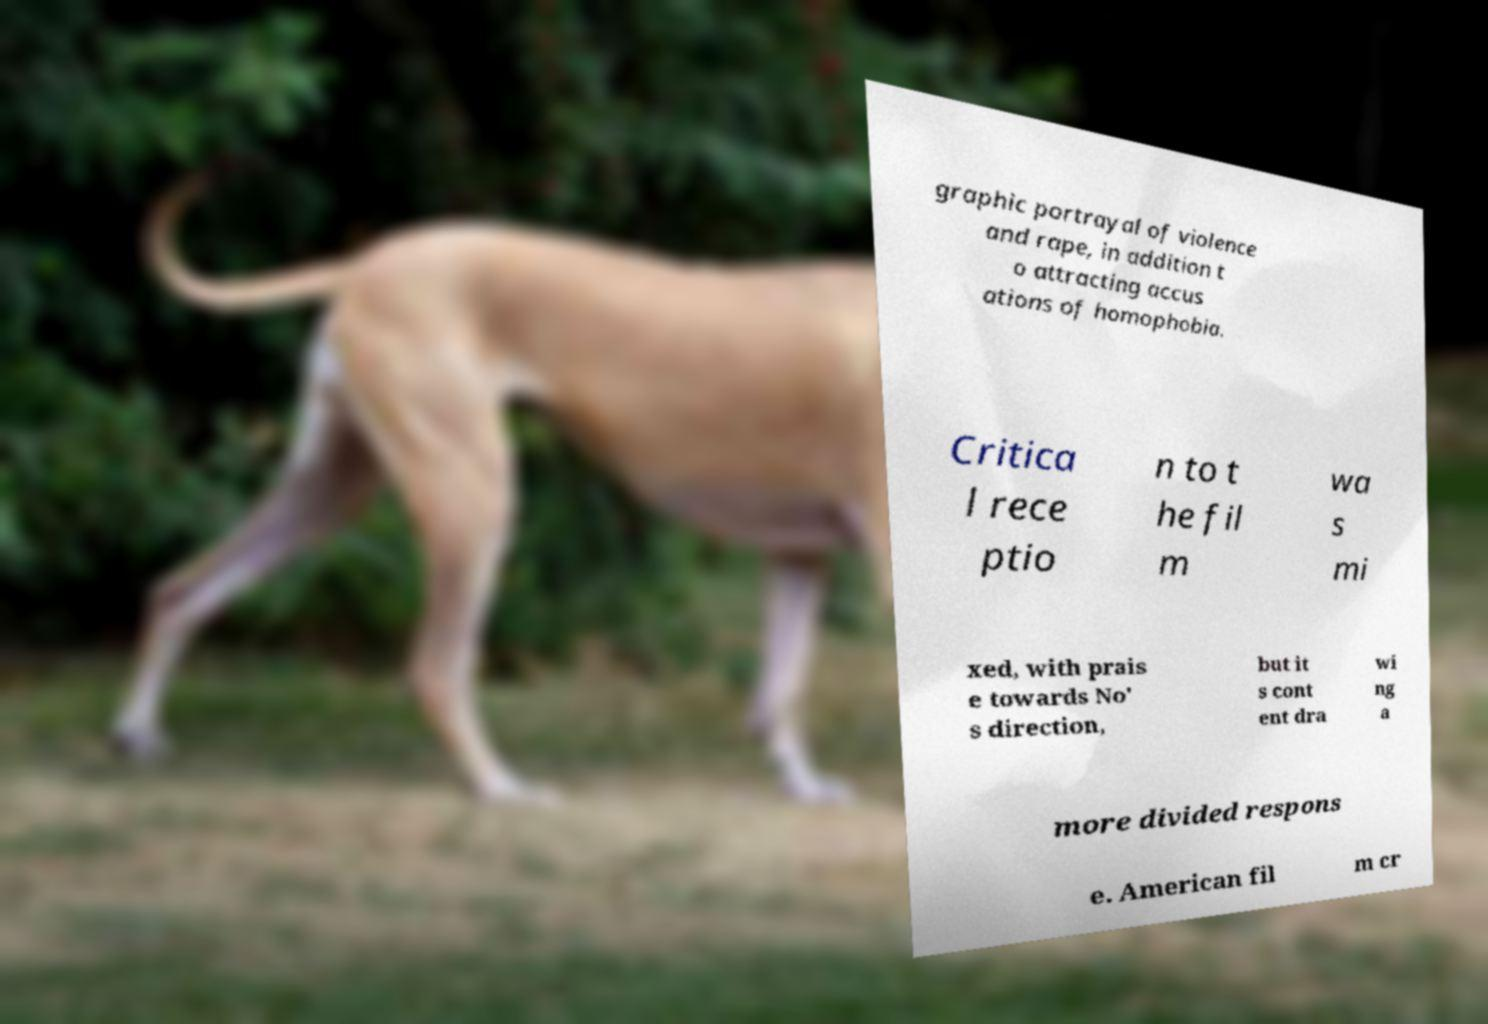What messages or text are displayed in this image? I need them in a readable, typed format. graphic portrayal of violence and rape, in addition t o attracting accus ations of homophobia. Critica l rece ptio n to t he fil m wa s mi xed, with prais e towards No' s direction, but it s cont ent dra wi ng a more divided respons e. American fil m cr 